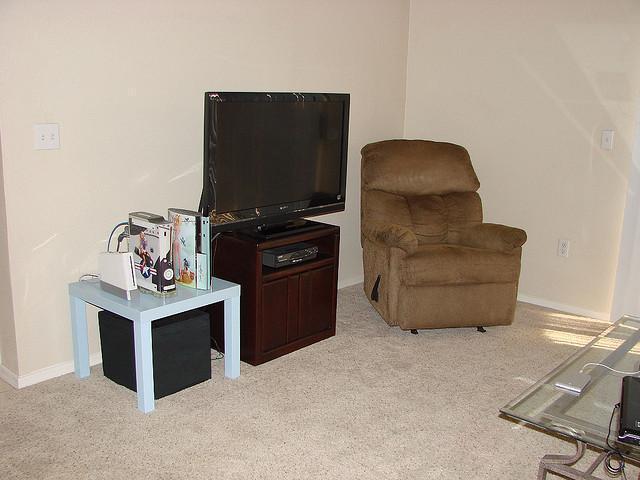How many tvs are there?
Give a very brief answer. 1. How many books are there?
Give a very brief answer. 2. How many bananas have stickers on them?
Give a very brief answer. 0. 